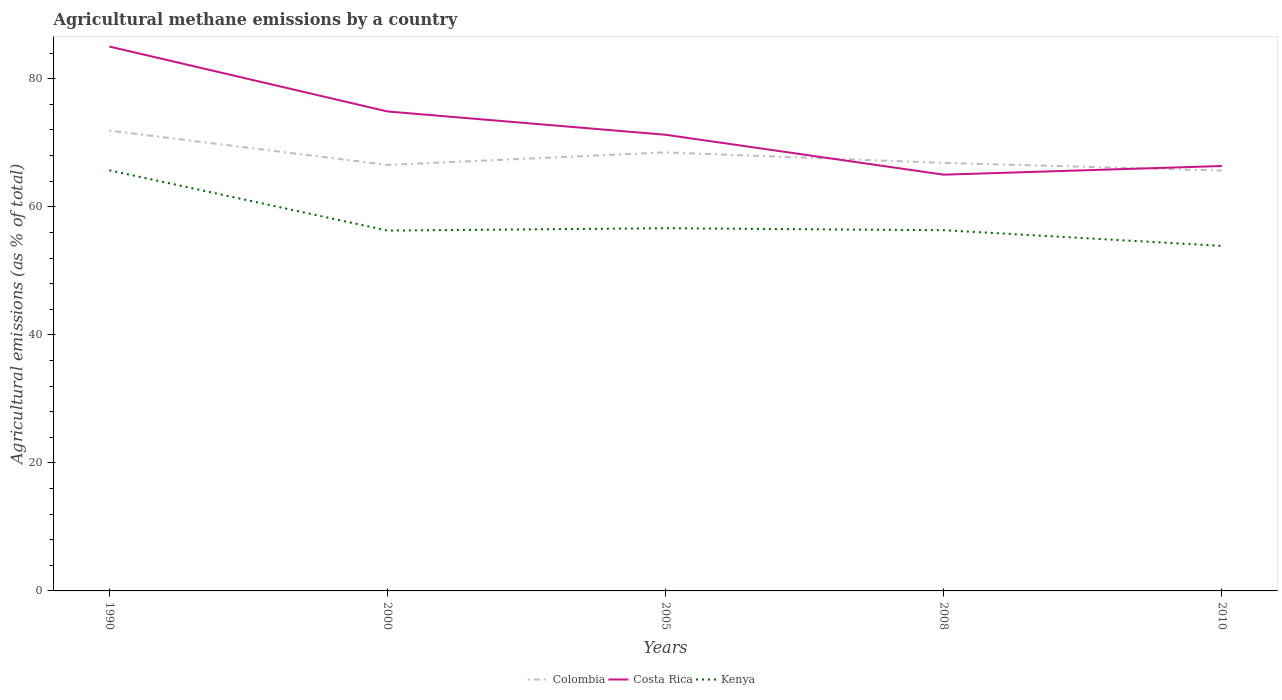Is the number of lines equal to the number of legend labels?
Give a very brief answer. Yes. Across all years, what is the maximum amount of agricultural methane emitted in Colombia?
Make the answer very short. 65.66. What is the total amount of agricultural methane emitted in Colombia in the graph?
Offer a very short reply. 0.88. What is the difference between the highest and the second highest amount of agricultural methane emitted in Costa Rica?
Your answer should be very brief. 20.02. What is the difference between the highest and the lowest amount of agricultural methane emitted in Kenya?
Offer a very short reply. 1. How many lines are there?
Ensure brevity in your answer.  3. How many years are there in the graph?
Ensure brevity in your answer.  5. What is the difference between two consecutive major ticks on the Y-axis?
Provide a succinct answer. 20. Are the values on the major ticks of Y-axis written in scientific E-notation?
Your answer should be compact. No. Does the graph contain grids?
Offer a terse response. No. Where does the legend appear in the graph?
Make the answer very short. Bottom center. How many legend labels are there?
Make the answer very short. 3. What is the title of the graph?
Provide a succinct answer. Agricultural methane emissions by a country. What is the label or title of the Y-axis?
Provide a short and direct response. Agricultural emissions (as % of total). What is the Agricultural emissions (as % of total) in Colombia in 1990?
Offer a terse response. 71.91. What is the Agricultural emissions (as % of total) in Costa Rica in 1990?
Ensure brevity in your answer.  85.04. What is the Agricultural emissions (as % of total) of Kenya in 1990?
Keep it short and to the point. 65.71. What is the Agricultural emissions (as % of total) in Colombia in 2000?
Provide a succinct answer. 66.54. What is the Agricultural emissions (as % of total) in Costa Rica in 2000?
Your answer should be very brief. 74.89. What is the Agricultural emissions (as % of total) in Kenya in 2000?
Your answer should be compact. 56.29. What is the Agricultural emissions (as % of total) in Colombia in 2005?
Provide a short and direct response. 68.5. What is the Agricultural emissions (as % of total) of Costa Rica in 2005?
Make the answer very short. 71.26. What is the Agricultural emissions (as % of total) in Kenya in 2005?
Give a very brief answer. 56.66. What is the Agricultural emissions (as % of total) of Colombia in 2008?
Ensure brevity in your answer.  66.86. What is the Agricultural emissions (as % of total) in Costa Rica in 2008?
Your answer should be very brief. 65.02. What is the Agricultural emissions (as % of total) in Kenya in 2008?
Ensure brevity in your answer.  56.35. What is the Agricultural emissions (as % of total) of Colombia in 2010?
Provide a short and direct response. 65.66. What is the Agricultural emissions (as % of total) of Costa Rica in 2010?
Ensure brevity in your answer.  66.38. What is the Agricultural emissions (as % of total) in Kenya in 2010?
Keep it short and to the point. 53.9. Across all years, what is the maximum Agricultural emissions (as % of total) in Colombia?
Offer a very short reply. 71.91. Across all years, what is the maximum Agricultural emissions (as % of total) in Costa Rica?
Ensure brevity in your answer.  85.04. Across all years, what is the maximum Agricultural emissions (as % of total) of Kenya?
Your response must be concise. 65.71. Across all years, what is the minimum Agricultural emissions (as % of total) in Colombia?
Your response must be concise. 65.66. Across all years, what is the minimum Agricultural emissions (as % of total) of Costa Rica?
Offer a very short reply. 65.02. Across all years, what is the minimum Agricultural emissions (as % of total) in Kenya?
Your answer should be compact. 53.9. What is the total Agricultural emissions (as % of total) in Colombia in the graph?
Make the answer very short. 339.47. What is the total Agricultural emissions (as % of total) in Costa Rica in the graph?
Make the answer very short. 362.58. What is the total Agricultural emissions (as % of total) of Kenya in the graph?
Your response must be concise. 288.9. What is the difference between the Agricultural emissions (as % of total) of Colombia in 1990 and that in 2000?
Ensure brevity in your answer.  5.36. What is the difference between the Agricultural emissions (as % of total) in Costa Rica in 1990 and that in 2000?
Give a very brief answer. 10.14. What is the difference between the Agricultural emissions (as % of total) of Kenya in 1990 and that in 2000?
Your answer should be compact. 9.42. What is the difference between the Agricultural emissions (as % of total) in Colombia in 1990 and that in 2005?
Give a very brief answer. 3.4. What is the difference between the Agricultural emissions (as % of total) of Costa Rica in 1990 and that in 2005?
Keep it short and to the point. 13.78. What is the difference between the Agricultural emissions (as % of total) of Kenya in 1990 and that in 2005?
Your answer should be very brief. 9.05. What is the difference between the Agricultural emissions (as % of total) in Colombia in 1990 and that in 2008?
Make the answer very short. 5.04. What is the difference between the Agricultural emissions (as % of total) in Costa Rica in 1990 and that in 2008?
Give a very brief answer. 20.02. What is the difference between the Agricultural emissions (as % of total) in Kenya in 1990 and that in 2008?
Offer a terse response. 9.36. What is the difference between the Agricultural emissions (as % of total) of Colombia in 1990 and that in 2010?
Your answer should be compact. 6.25. What is the difference between the Agricultural emissions (as % of total) in Costa Rica in 1990 and that in 2010?
Offer a terse response. 18.66. What is the difference between the Agricultural emissions (as % of total) of Kenya in 1990 and that in 2010?
Provide a short and direct response. 11.81. What is the difference between the Agricultural emissions (as % of total) in Colombia in 2000 and that in 2005?
Offer a very short reply. -1.96. What is the difference between the Agricultural emissions (as % of total) of Costa Rica in 2000 and that in 2005?
Offer a terse response. 3.64. What is the difference between the Agricultural emissions (as % of total) in Kenya in 2000 and that in 2005?
Offer a terse response. -0.37. What is the difference between the Agricultural emissions (as % of total) of Colombia in 2000 and that in 2008?
Give a very brief answer. -0.32. What is the difference between the Agricultural emissions (as % of total) of Costa Rica in 2000 and that in 2008?
Offer a terse response. 9.87. What is the difference between the Agricultural emissions (as % of total) in Kenya in 2000 and that in 2008?
Offer a very short reply. -0.06. What is the difference between the Agricultural emissions (as % of total) in Colombia in 2000 and that in 2010?
Provide a short and direct response. 0.88. What is the difference between the Agricultural emissions (as % of total) of Costa Rica in 2000 and that in 2010?
Offer a very short reply. 8.52. What is the difference between the Agricultural emissions (as % of total) in Kenya in 2000 and that in 2010?
Keep it short and to the point. 2.39. What is the difference between the Agricultural emissions (as % of total) in Colombia in 2005 and that in 2008?
Your answer should be compact. 1.64. What is the difference between the Agricultural emissions (as % of total) in Costa Rica in 2005 and that in 2008?
Ensure brevity in your answer.  6.23. What is the difference between the Agricultural emissions (as % of total) in Kenya in 2005 and that in 2008?
Provide a succinct answer. 0.31. What is the difference between the Agricultural emissions (as % of total) of Colombia in 2005 and that in 2010?
Your answer should be compact. 2.84. What is the difference between the Agricultural emissions (as % of total) in Costa Rica in 2005 and that in 2010?
Ensure brevity in your answer.  4.88. What is the difference between the Agricultural emissions (as % of total) in Kenya in 2005 and that in 2010?
Your answer should be compact. 2.76. What is the difference between the Agricultural emissions (as % of total) in Colombia in 2008 and that in 2010?
Offer a very short reply. 1.2. What is the difference between the Agricultural emissions (as % of total) of Costa Rica in 2008 and that in 2010?
Offer a terse response. -1.35. What is the difference between the Agricultural emissions (as % of total) of Kenya in 2008 and that in 2010?
Offer a very short reply. 2.45. What is the difference between the Agricultural emissions (as % of total) of Colombia in 1990 and the Agricultural emissions (as % of total) of Costa Rica in 2000?
Your answer should be compact. -2.99. What is the difference between the Agricultural emissions (as % of total) in Colombia in 1990 and the Agricultural emissions (as % of total) in Kenya in 2000?
Provide a short and direct response. 15.62. What is the difference between the Agricultural emissions (as % of total) of Costa Rica in 1990 and the Agricultural emissions (as % of total) of Kenya in 2000?
Your answer should be very brief. 28.75. What is the difference between the Agricultural emissions (as % of total) in Colombia in 1990 and the Agricultural emissions (as % of total) in Costa Rica in 2005?
Your answer should be very brief. 0.65. What is the difference between the Agricultural emissions (as % of total) in Colombia in 1990 and the Agricultural emissions (as % of total) in Kenya in 2005?
Provide a succinct answer. 15.25. What is the difference between the Agricultural emissions (as % of total) in Costa Rica in 1990 and the Agricultural emissions (as % of total) in Kenya in 2005?
Your answer should be compact. 28.38. What is the difference between the Agricultural emissions (as % of total) of Colombia in 1990 and the Agricultural emissions (as % of total) of Costa Rica in 2008?
Give a very brief answer. 6.88. What is the difference between the Agricultural emissions (as % of total) in Colombia in 1990 and the Agricultural emissions (as % of total) in Kenya in 2008?
Provide a short and direct response. 15.56. What is the difference between the Agricultural emissions (as % of total) of Costa Rica in 1990 and the Agricultural emissions (as % of total) of Kenya in 2008?
Offer a very short reply. 28.69. What is the difference between the Agricultural emissions (as % of total) in Colombia in 1990 and the Agricultural emissions (as % of total) in Costa Rica in 2010?
Your answer should be very brief. 5.53. What is the difference between the Agricultural emissions (as % of total) of Colombia in 1990 and the Agricultural emissions (as % of total) of Kenya in 2010?
Provide a succinct answer. 18.01. What is the difference between the Agricultural emissions (as % of total) of Costa Rica in 1990 and the Agricultural emissions (as % of total) of Kenya in 2010?
Give a very brief answer. 31.14. What is the difference between the Agricultural emissions (as % of total) in Colombia in 2000 and the Agricultural emissions (as % of total) in Costa Rica in 2005?
Your answer should be very brief. -4.71. What is the difference between the Agricultural emissions (as % of total) in Colombia in 2000 and the Agricultural emissions (as % of total) in Kenya in 2005?
Give a very brief answer. 9.89. What is the difference between the Agricultural emissions (as % of total) of Costa Rica in 2000 and the Agricultural emissions (as % of total) of Kenya in 2005?
Ensure brevity in your answer.  18.24. What is the difference between the Agricultural emissions (as % of total) of Colombia in 2000 and the Agricultural emissions (as % of total) of Costa Rica in 2008?
Provide a succinct answer. 1.52. What is the difference between the Agricultural emissions (as % of total) of Colombia in 2000 and the Agricultural emissions (as % of total) of Kenya in 2008?
Give a very brief answer. 10.2. What is the difference between the Agricultural emissions (as % of total) of Costa Rica in 2000 and the Agricultural emissions (as % of total) of Kenya in 2008?
Your answer should be very brief. 18.55. What is the difference between the Agricultural emissions (as % of total) of Colombia in 2000 and the Agricultural emissions (as % of total) of Kenya in 2010?
Provide a succinct answer. 12.65. What is the difference between the Agricultural emissions (as % of total) in Costa Rica in 2000 and the Agricultural emissions (as % of total) in Kenya in 2010?
Your response must be concise. 21. What is the difference between the Agricultural emissions (as % of total) in Colombia in 2005 and the Agricultural emissions (as % of total) in Costa Rica in 2008?
Your response must be concise. 3.48. What is the difference between the Agricultural emissions (as % of total) in Colombia in 2005 and the Agricultural emissions (as % of total) in Kenya in 2008?
Provide a succinct answer. 12.16. What is the difference between the Agricultural emissions (as % of total) in Costa Rica in 2005 and the Agricultural emissions (as % of total) in Kenya in 2008?
Your response must be concise. 14.91. What is the difference between the Agricultural emissions (as % of total) in Colombia in 2005 and the Agricultural emissions (as % of total) in Costa Rica in 2010?
Ensure brevity in your answer.  2.13. What is the difference between the Agricultural emissions (as % of total) in Colombia in 2005 and the Agricultural emissions (as % of total) in Kenya in 2010?
Your answer should be compact. 14.61. What is the difference between the Agricultural emissions (as % of total) in Costa Rica in 2005 and the Agricultural emissions (as % of total) in Kenya in 2010?
Offer a very short reply. 17.36. What is the difference between the Agricultural emissions (as % of total) in Colombia in 2008 and the Agricultural emissions (as % of total) in Costa Rica in 2010?
Provide a short and direct response. 0.49. What is the difference between the Agricultural emissions (as % of total) in Colombia in 2008 and the Agricultural emissions (as % of total) in Kenya in 2010?
Keep it short and to the point. 12.97. What is the difference between the Agricultural emissions (as % of total) in Costa Rica in 2008 and the Agricultural emissions (as % of total) in Kenya in 2010?
Offer a terse response. 11.12. What is the average Agricultural emissions (as % of total) of Colombia per year?
Offer a terse response. 67.89. What is the average Agricultural emissions (as % of total) in Costa Rica per year?
Make the answer very short. 72.52. What is the average Agricultural emissions (as % of total) in Kenya per year?
Your answer should be very brief. 57.78. In the year 1990, what is the difference between the Agricultural emissions (as % of total) in Colombia and Agricultural emissions (as % of total) in Costa Rica?
Your answer should be very brief. -13.13. In the year 1990, what is the difference between the Agricultural emissions (as % of total) in Colombia and Agricultural emissions (as % of total) in Kenya?
Give a very brief answer. 6.2. In the year 1990, what is the difference between the Agricultural emissions (as % of total) of Costa Rica and Agricultural emissions (as % of total) of Kenya?
Your answer should be compact. 19.33. In the year 2000, what is the difference between the Agricultural emissions (as % of total) in Colombia and Agricultural emissions (as % of total) in Costa Rica?
Give a very brief answer. -8.35. In the year 2000, what is the difference between the Agricultural emissions (as % of total) of Colombia and Agricultural emissions (as % of total) of Kenya?
Your response must be concise. 10.25. In the year 2000, what is the difference between the Agricultural emissions (as % of total) in Costa Rica and Agricultural emissions (as % of total) in Kenya?
Provide a short and direct response. 18.6. In the year 2005, what is the difference between the Agricultural emissions (as % of total) of Colombia and Agricultural emissions (as % of total) of Costa Rica?
Make the answer very short. -2.75. In the year 2005, what is the difference between the Agricultural emissions (as % of total) of Colombia and Agricultural emissions (as % of total) of Kenya?
Offer a terse response. 11.85. In the year 2005, what is the difference between the Agricultural emissions (as % of total) of Costa Rica and Agricultural emissions (as % of total) of Kenya?
Offer a terse response. 14.6. In the year 2008, what is the difference between the Agricultural emissions (as % of total) in Colombia and Agricultural emissions (as % of total) in Costa Rica?
Offer a very short reply. 1.84. In the year 2008, what is the difference between the Agricultural emissions (as % of total) of Colombia and Agricultural emissions (as % of total) of Kenya?
Ensure brevity in your answer.  10.52. In the year 2008, what is the difference between the Agricultural emissions (as % of total) in Costa Rica and Agricultural emissions (as % of total) in Kenya?
Offer a terse response. 8.68. In the year 2010, what is the difference between the Agricultural emissions (as % of total) of Colombia and Agricultural emissions (as % of total) of Costa Rica?
Provide a succinct answer. -0.72. In the year 2010, what is the difference between the Agricultural emissions (as % of total) of Colombia and Agricultural emissions (as % of total) of Kenya?
Your response must be concise. 11.76. In the year 2010, what is the difference between the Agricultural emissions (as % of total) of Costa Rica and Agricultural emissions (as % of total) of Kenya?
Make the answer very short. 12.48. What is the ratio of the Agricultural emissions (as % of total) of Colombia in 1990 to that in 2000?
Your response must be concise. 1.08. What is the ratio of the Agricultural emissions (as % of total) of Costa Rica in 1990 to that in 2000?
Make the answer very short. 1.14. What is the ratio of the Agricultural emissions (as % of total) of Kenya in 1990 to that in 2000?
Offer a terse response. 1.17. What is the ratio of the Agricultural emissions (as % of total) of Colombia in 1990 to that in 2005?
Give a very brief answer. 1.05. What is the ratio of the Agricultural emissions (as % of total) in Costa Rica in 1990 to that in 2005?
Provide a succinct answer. 1.19. What is the ratio of the Agricultural emissions (as % of total) in Kenya in 1990 to that in 2005?
Your response must be concise. 1.16. What is the ratio of the Agricultural emissions (as % of total) of Colombia in 1990 to that in 2008?
Give a very brief answer. 1.08. What is the ratio of the Agricultural emissions (as % of total) in Costa Rica in 1990 to that in 2008?
Offer a terse response. 1.31. What is the ratio of the Agricultural emissions (as % of total) in Kenya in 1990 to that in 2008?
Offer a terse response. 1.17. What is the ratio of the Agricultural emissions (as % of total) in Colombia in 1990 to that in 2010?
Keep it short and to the point. 1.1. What is the ratio of the Agricultural emissions (as % of total) in Costa Rica in 1990 to that in 2010?
Offer a very short reply. 1.28. What is the ratio of the Agricultural emissions (as % of total) of Kenya in 1990 to that in 2010?
Provide a short and direct response. 1.22. What is the ratio of the Agricultural emissions (as % of total) in Colombia in 2000 to that in 2005?
Provide a short and direct response. 0.97. What is the ratio of the Agricultural emissions (as % of total) of Costa Rica in 2000 to that in 2005?
Make the answer very short. 1.05. What is the ratio of the Agricultural emissions (as % of total) in Costa Rica in 2000 to that in 2008?
Your answer should be compact. 1.15. What is the ratio of the Agricultural emissions (as % of total) of Colombia in 2000 to that in 2010?
Offer a very short reply. 1.01. What is the ratio of the Agricultural emissions (as % of total) of Costa Rica in 2000 to that in 2010?
Give a very brief answer. 1.13. What is the ratio of the Agricultural emissions (as % of total) of Kenya in 2000 to that in 2010?
Make the answer very short. 1.04. What is the ratio of the Agricultural emissions (as % of total) of Colombia in 2005 to that in 2008?
Provide a succinct answer. 1.02. What is the ratio of the Agricultural emissions (as % of total) of Costa Rica in 2005 to that in 2008?
Ensure brevity in your answer.  1.1. What is the ratio of the Agricultural emissions (as % of total) in Kenya in 2005 to that in 2008?
Keep it short and to the point. 1.01. What is the ratio of the Agricultural emissions (as % of total) in Colombia in 2005 to that in 2010?
Make the answer very short. 1.04. What is the ratio of the Agricultural emissions (as % of total) of Costa Rica in 2005 to that in 2010?
Ensure brevity in your answer.  1.07. What is the ratio of the Agricultural emissions (as % of total) in Kenya in 2005 to that in 2010?
Keep it short and to the point. 1.05. What is the ratio of the Agricultural emissions (as % of total) of Colombia in 2008 to that in 2010?
Keep it short and to the point. 1.02. What is the ratio of the Agricultural emissions (as % of total) of Costa Rica in 2008 to that in 2010?
Offer a very short reply. 0.98. What is the ratio of the Agricultural emissions (as % of total) of Kenya in 2008 to that in 2010?
Make the answer very short. 1.05. What is the difference between the highest and the second highest Agricultural emissions (as % of total) in Colombia?
Give a very brief answer. 3.4. What is the difference between the highest and the second highest Agricultural emissions (as % of total) of Costa Rica?
Keep it short and to the point. 10.14. What is the difference between the highest and the second highest Agricultural emissions (as % of total) of Kenya?
Your answer should be very brief. 9.05. What is the difference between the highest and the lowest Agricultural emissions (as % of total) in Colombia?
Offer a very short reply. 6.25. What is the difference between the highest and the lowest Agricultural emissions (as % of total) in Costa Rica?
Give a very brief answer. 20.02. What is the difference between the highest and the lowest Agricultural emissions (as % of total) in Kenya?
Your answer should be very brief. 11.81. 